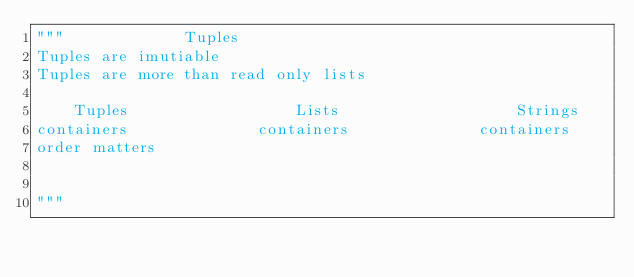Convert code to text. <code><loc_0><loc_0><loc_500><loc_500><_Python_>"""             Tuples
Tuples are imutiable
Tuples are more than read only lists

    Tuples                  Lists                   Strings
containers              containers              containers
order matters           


"""</code> 